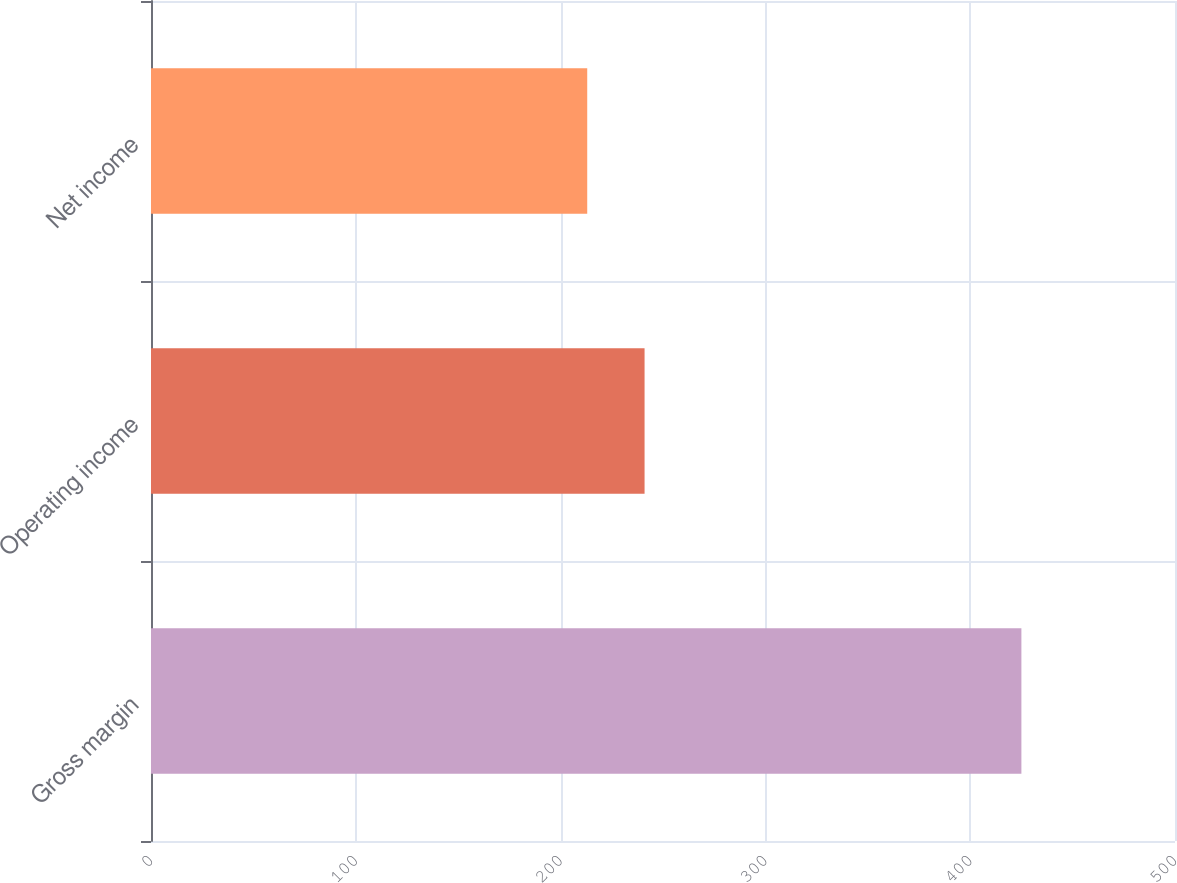<chart> <loc_0><loc_0><loc_500><loc_500><bar_chart><fcel>Gross margin<fcel>Operating income<fcel>Net income<nl><fcel>425<fcel>241<fcel>213<nl></chart> 